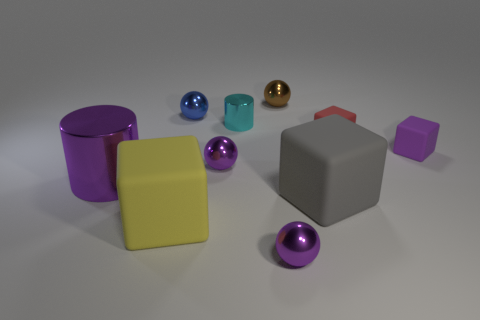Subtract all spheres. How many objects are left? 6 Subtract 0 yellow cylinders. How many objects are left? 10 Subtract all purple cubes. Subtract all blue objects. How many objects are left? 8 Add 3 brown metal things. How many brown metal things are left? 4 Add 10 purple rubber balls. How many purple rubber balls exist? 10 